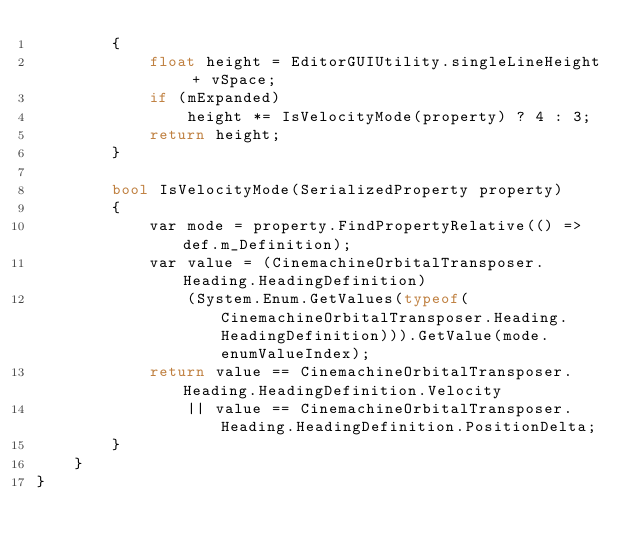<code> <loc_0><loc_0><loc_500><loc_500><_C#_>        {
            float height = EditorGUIUtility.singleLineHeight + vSpace;
            if (mExpanded)
                height *= IsVelocityMode(property) ? 4 : 3;
            return height;
        }

        bool IsVelocityMode(SerializedProperty property)
        {
            var mode = property.FindPropertyRelative(() => def.m_Definition);
            var value = (CinemachineOrbitalTransposer.Heading.HeadingDefinition)
                (System.Enum.GetValues(typeof(CinemachineOrbitalTransposer.Heading.HeadingDefinition))).GetValue(mode.enumValueIndex);
            return value == CinemachineOrbitalTransposer.Heading.HeadingDefinition.Velocity
                || value == CinemachineOrbitalTransposer.Heading.HeadingDefinition.PositionDelta;
        }
    }
}
</code> 